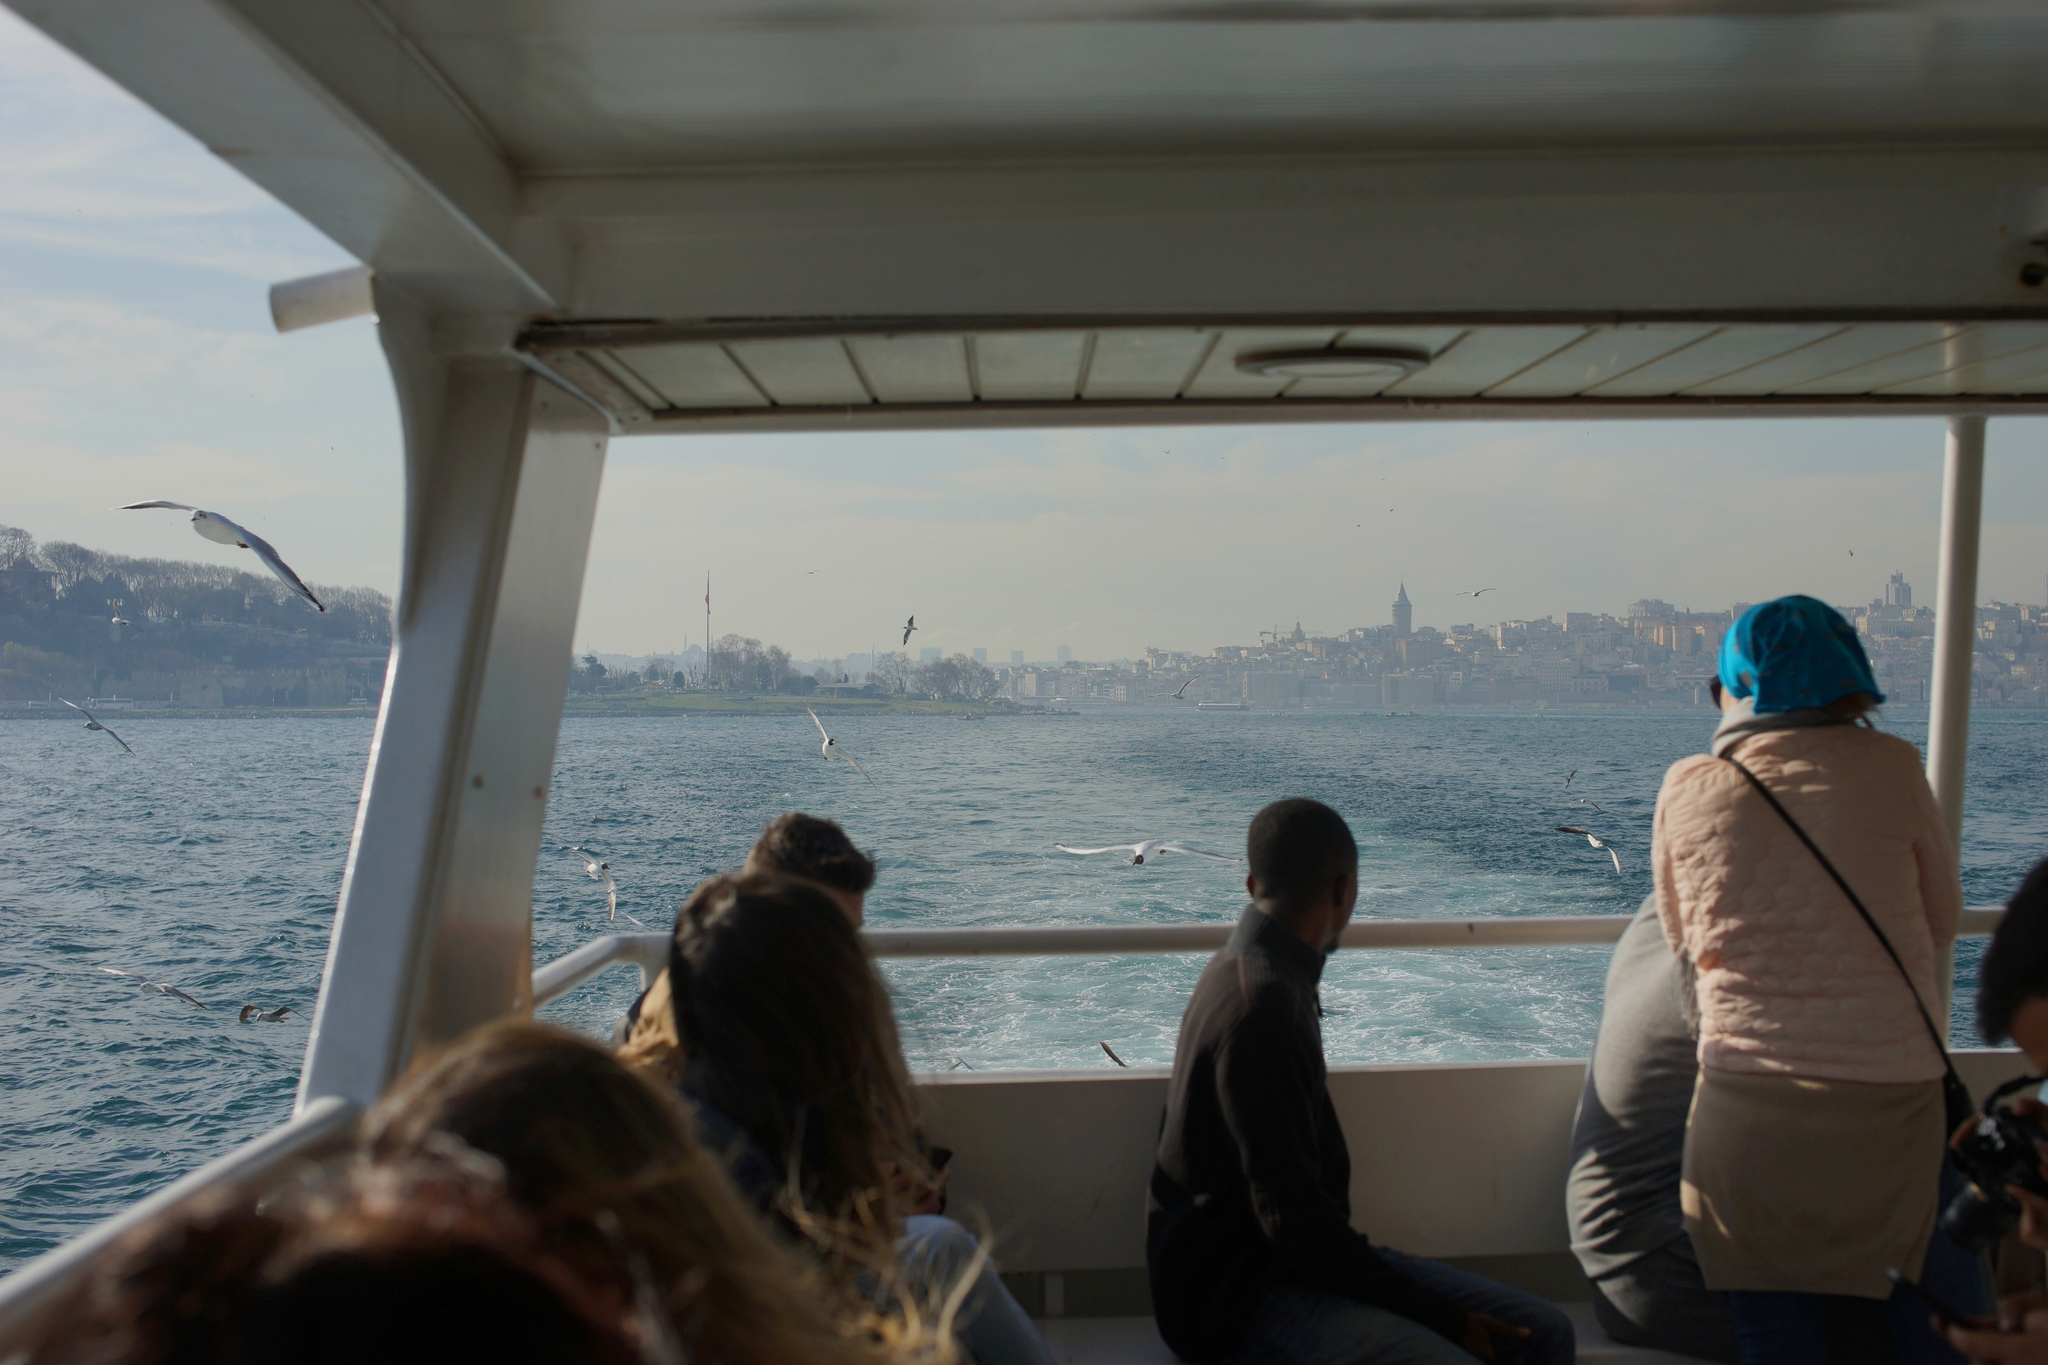Can you describe the ethos or ambiance this picture portrays? The image evokes a sense of tranquil exploration and cultural immersion. The casual clothing of the passengers and their serene expressions suggest they are in a relaxed state of mind, enjoying a break from their daily routines. The presence of historical architecture juxtaposed with the modern cityscape implies a rich, layered history, inviting the viewer to ponder the stories and heritage of the place. The natural elements – the clear blue water and the flying seagulls – add a layer of calm and connection to nature, creating a balanced and harmonious atmosphere. This combination of peacefulness and curiosity paints a picture of leisurely adventuring intertwined with cultural discovery. What might be the history behind this city’s skyline? The city's skyline tells a story of a place where history and progress have gone hand in hand. The prominent minaret suggests a strong cultural and religious history, possibly indicative of a significant historical era where mosques and religious structures played central roles in community life. The presence of both older, historical structures and new, modern buildings hints at a city that values its heritage while embracing contemporary advancement. Such a skyline could represent decades or even centuries of architectural evolution, societal changes, and historical events that have shaped the city's identity. The mixture of architectural styles suggests that the city has undergone various periods of influence, possibly from different empires or cultures that left their mark over time. Imagine what kind of stories the passengers on the boat might be sharing. The stories shared among the passengers on the boat could be as diverse as their backgrounds. A tourist might be narrating the wonders they've discovered in the city's historic districts, sharing tales of ancient sites and local legends. Another might be discussing the vibrant local markets filled with exotic spices, handmade crafts, and the irresistible aroma of street food. A local resident could be reminiscing about their childhood escapades along the waterfront, or retelling tales of festivals and celebrations that bring the city to life. Perhaps, a couple is sharing a nostalgic moment, recalling a similar boat ride from years past, now creating new memories to cherish. These shared stories might intertwine personal experiences with the rich tapestry of the city's history, weaving a collective memory that leaves a lasting imprint on all aboard. If this boat trip were to unexpectedly take passengers back in time, which era would you choose and why? If the boat were to transport its passengers back in time, a fascinating era to visit would be the height of the Ottoman Empire. During this period, the city's landscape flourished with majestic mosques, palaces, and bustling bazaars, vibrant with trade and culture. The passengers would witness the construction of timeless architectural wonders and experience the rich cultural amalgamation resulting from the empire's vast reach. It would be an opportunity to observe a pivotal chapter in history where arts, science, and philosophy thrived. Experiencing this era firsthand would provide a deep understanding of the historical significance and the cultural evolution that has shaped the city as seen today. 